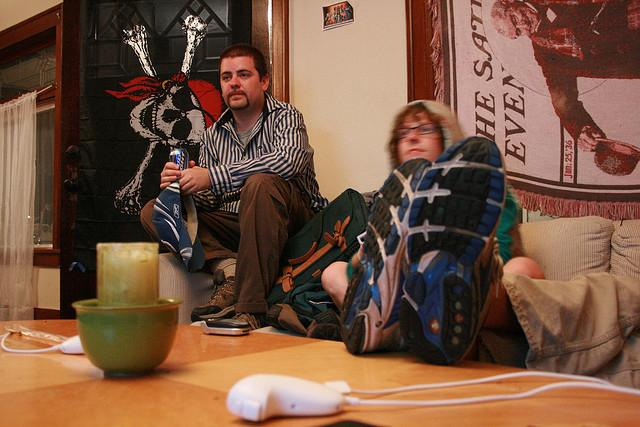What is the man on the left drinking?

Choices:
A) juice
B) wine
C) water
D) beer beer 